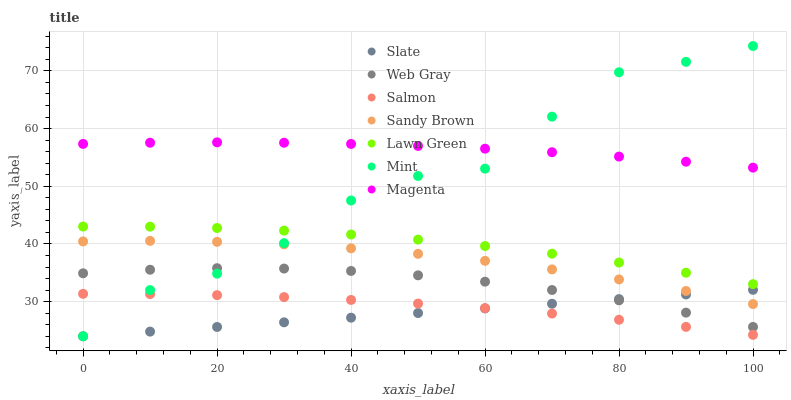Does Slate have the minimum area under the curve?
Answer yes or no. Yes. Does Magenta have the maximum area under the curve?
Answer yes or no. Yes. Does Web Gray have the minimum area under the curve?
Answer yes or no. No. Does Web Gray have the maximum area under the curve?
Answer yes or no. No. Is Slate the smoothest?
Answer yes or no. Yes. Is Mint the roughest?
Answer yes or no. Yes. Is Web Gray the smoothest?
Answer yes or no. No. Is Web Gray the roughest?
Answer yes or no. No. Does Mint have the lowest value?
Answer yes or no. Yes. Does Web Gray have the lowest value?
Answer yes or no. No. Does Mint have the highest value?
Answer yes or no. Yes. Does Web Gray have the highest value?
Answer yes or no. No. Is Slate less than Lawn Green?
Answer yes or no. Yes. Is Magenta greater than Sandy Brown?
Answer yes or no. Yes. Does Sandy Brown intersect Mint?
Answer yes or no. Yes. Is Sandy Brown less than Mint?
Answer yes or no. No. Is Sandy Brown greater than Mint?
Answer yes or no. No. Does Slate intersect Lawn Green?
Answer yes or no. No. 